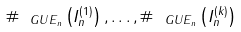<formula> <loc_0><loc_0><loc_500><loc_500>\# _ { \ G U E _ { n } } \left ( I _ { n } ^ { ( 1 ) } \right ) , \dots , \# _ { \ G U E _ { n } } \left ( I _ { n } ^ { ( k ) } \right )</formula> 